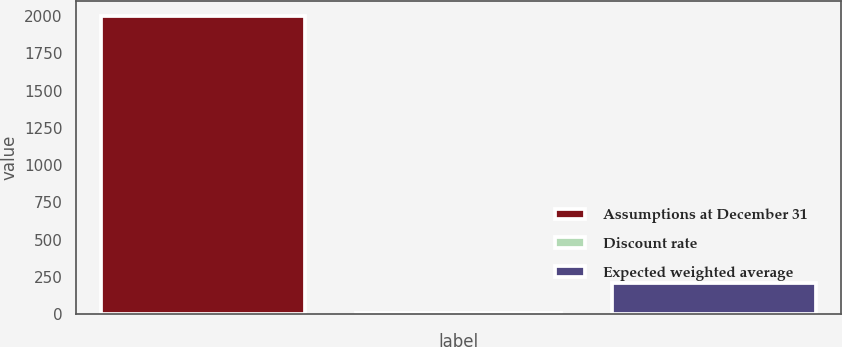Convert chart to OTSL. <chart><loc_0><loc_0><loc_500><loc_500><bar_chart><fcel>Assumptions at December 31<fcel>Discount rate<fcel>Expected weighted average<nl><fcel>2003<fcel>6.22<fcel>205.9<nl></chart> 